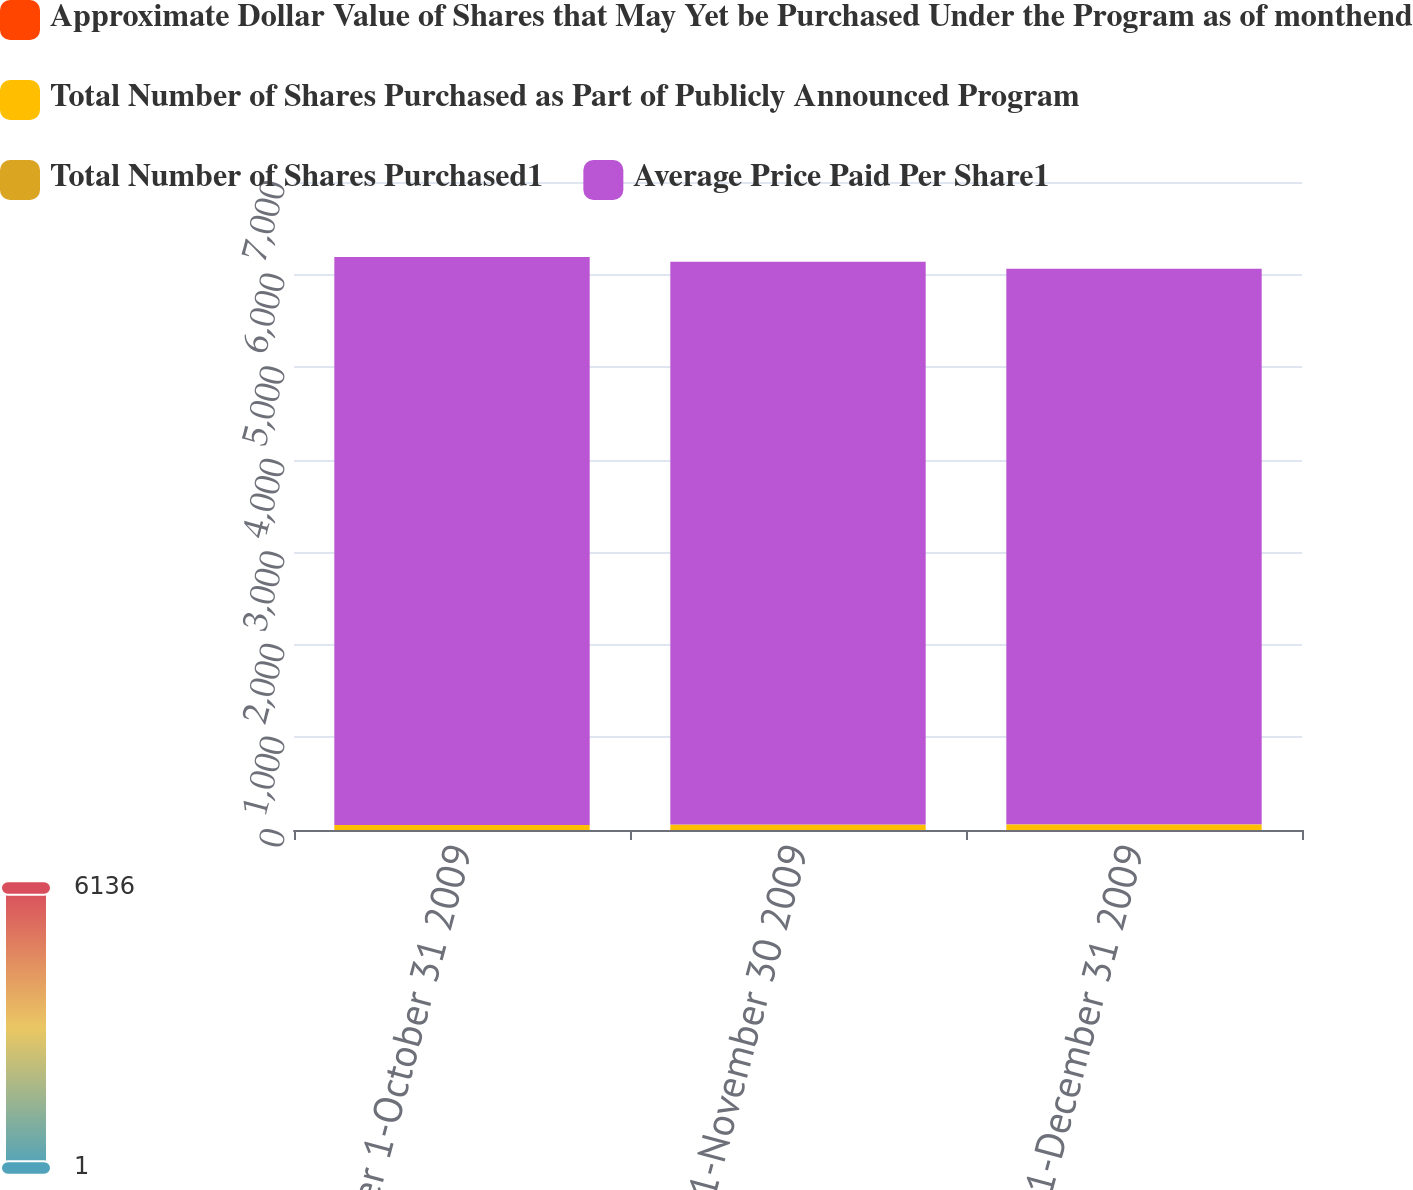<chart> <loc_0><loc_0><loc_500><loc_500><stacked_bar_chart><ecel><fcel>October 1-October 31 2009<fcel>November 1-November 30 2009<fcel>December 1-December 31 2009<nl><fcel>Approximate Dollar Value of Shares that May Yet be Purchased Under the Program as of monthend<fcel>0.9<fcel>1.3<fcel>1.3<nl><fcel>Total Number of Shares Purchased as Part of Publicly Announced Program<fcel>52.78<fcel>56.45<fcel>58.28<nl><fcel>Total Number of Shares Purchased1<fcel>0.8<fcel>1<fcel>1.3<nl><fcel>Average Price Paid Per Share1<fcel>6136<fcel>6080<fcel>6003<nl></chart> 